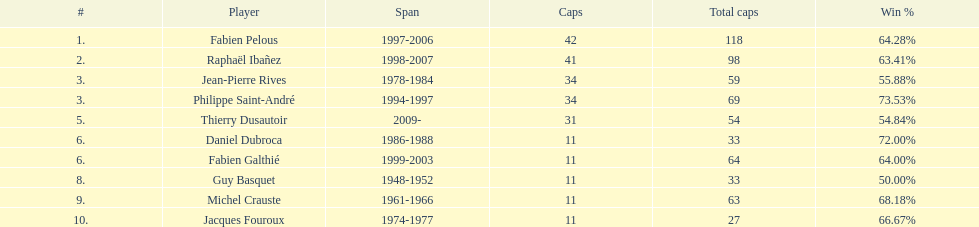Who possessed the highest victory proportion? Philippe Saint-André. 